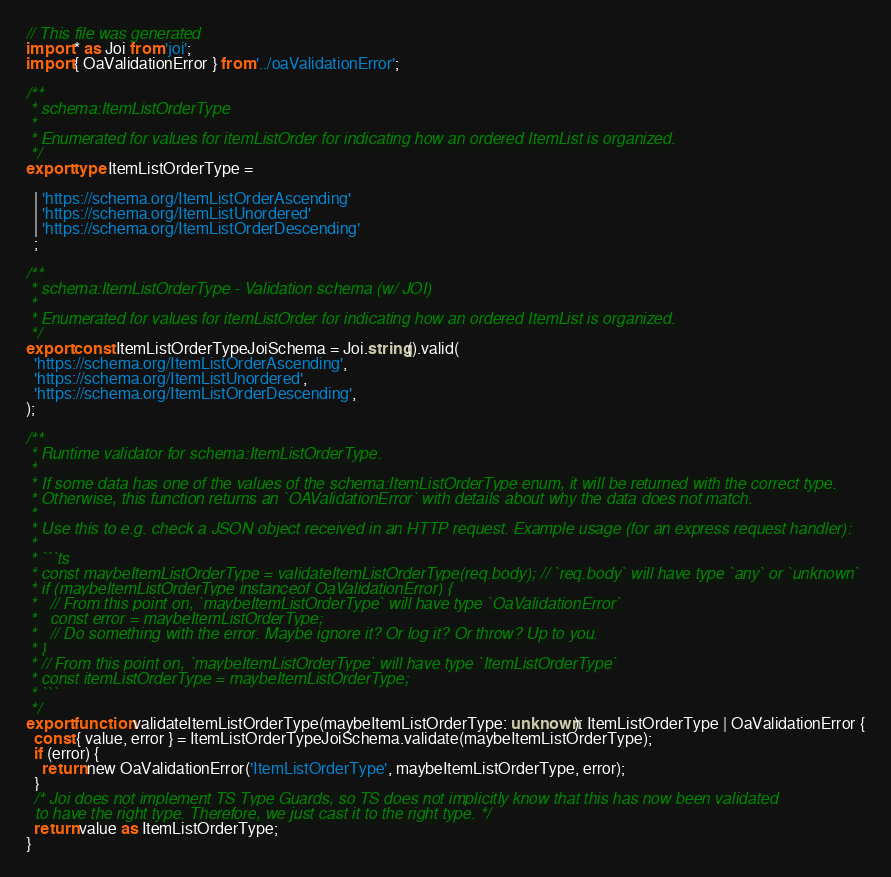<code> <loc_0><loc_0><loc_500><loc_500><_TypeScript_>// This file was generated
import * as Joi from 'joi';
import { OaValidationError } from '../oaValidationError';

/**
 * schema:ItemListOrderType
 *
 * Enumerated for values for itemListOrder for indicating how an ordered ItemList is organized.
 */
export type ItemListOrderType = 
  
  | 'https://schema.org/ItemListOrderAscending'
  | 'https://schema.org/ItemListUnordered'
  | 'https://schema.org/ItemListOrderDescending'
  ;

/**
 * schema:ItemListOrderType - Validation schema (w/ JOI)
 *
 * Enumerated for values for itemListOrder for indicating how an ordered ItemList is organized.
 */
export const ItemListOrderTypeJoiSchema = Joi.string().valid(
  'https://schema.org/ItemListOrderAscending',
  'https://schema.org/ItemListUnordered',
  'https://schema.org/ItemListOrderDescending',
);

/**
 * Runtime validator for schema:ItemListOrderType.
 *
 * If some data has one of the values of the schema:ItemListOrderType enum, it will be returned with the correct type.
 * Otherwise, this function returns an `OAValidationError` with details about why the data does not match.
 *
 * Use this to e.g. check a JSON object received in an HTTP request. Example usage (for an express request handler):
 *
 * ```ts
 * const maybeItemListOrderType = validateItemListOrderType(req.body); // `req.body` will have type `any` or `unknown`
 * if (maybeItemListOrderType instanceof OaValidationError) {
 *   // From this point on, `maybeItemListOrderType` will have type `OaValidationError`
 *   const error = maybeItemListOrderType;
 *   // Do something with the error. Maybe ignore it? Or log it? Or throw? Up to you.
 * }
 * // From this point on, `maybeItemListOrderType` will have type `ItemListOrderType`
 * const itemListOrderType = maybeItemListOrderType;
 * ```
 */
export function validateItemListOrderType(maybeItemListOrderType: unknown): ItemListOrderType | OaValidationError {
  const { value, error } = ItemListOrderTypeJoiSchema.validate(maybeItemListOrderType);
  if (error) {
    return new OaValidationError('ItemListOrderType', maybeItemListOrderType, error);
  }
  /* Joi does not implement TS Type Guards, so TS does not implicitly know that this has now been validated
  to have the right type. Therefore, we just cast it to the right type. */
  return value as ItemListOrderType;
}
</code> 